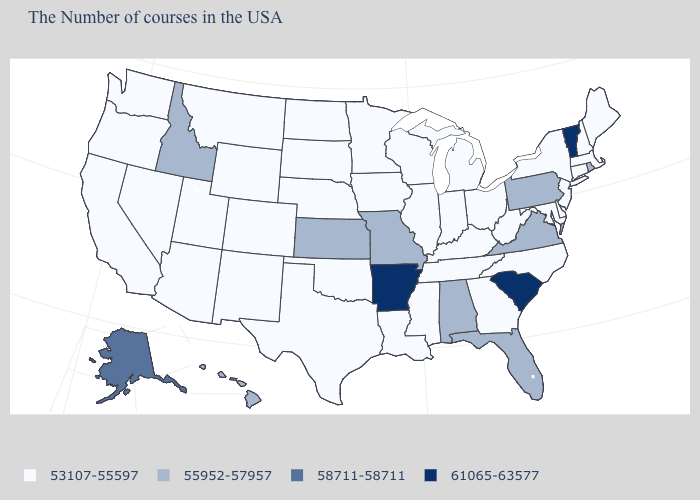Does Massachusetts have a lower value than Idaho?
Answer briefly. Yes. Does the first symbol in the legend represent the smallest category?
Concise answer only. Yes. Among the states that border Rhode Island , which have the highest value?
Short answer required. Massachusetts, Connecticut. Among the states that border Maine , which have the highest value?
Concise answer only. New Hampshire. What is the value of New Jersey?
Quick response, please. 53107-55597. Does Colorado have the lowest value in the USA?
Write a very short answer. Yes. Which states have the lowest value in the South?
Concise answer only. Delaware, Maryland, North Carolina, West Virginia, Georgia, Kentucky, Tennessee, Mississippi, Louisiana, Oklahoma, Texas. How many symbols are there in the legend?
Keep it brief. 4. Is the legend a continuous bar?
Write a very short answer. No. Among the states that border Maryland , does Delaware have the lowest value?
Give a very brief answer. Yes. Does Vermont have a higher value than Arkansas?
Answer briefly. No. What is the highest value in the South ?
Keep it brief. 61065-63577. Among the states that border Missouri , which have the lowest value?
Short answer required. Kentucky, Tennessee, Illinois, Iowa, Nebraska, Oklahoma. Does Virginia have the lowest value in the South?
Be succinct. No. Name the states that have a value in the range 53107-55597?
Answer briefly. Maine, Massachusetts, New Hampshire, Connecticut, New York, New Jersey, Delaware, Maryland, North Carolina, West Virginia, Ohio, Georgia, Michigan, Kentucky, Indiana, Tennessee, Wisconsin, Illinois, Mississippi, Louisiana, Minnesota, Iowa, Nebraska, Oklahoma, Texas, South Dakota, North Dakota, Wyoming, Colorado, New Mexico, Utah, Montana, Arizona, Nevada, California, Washington, Oregon. 